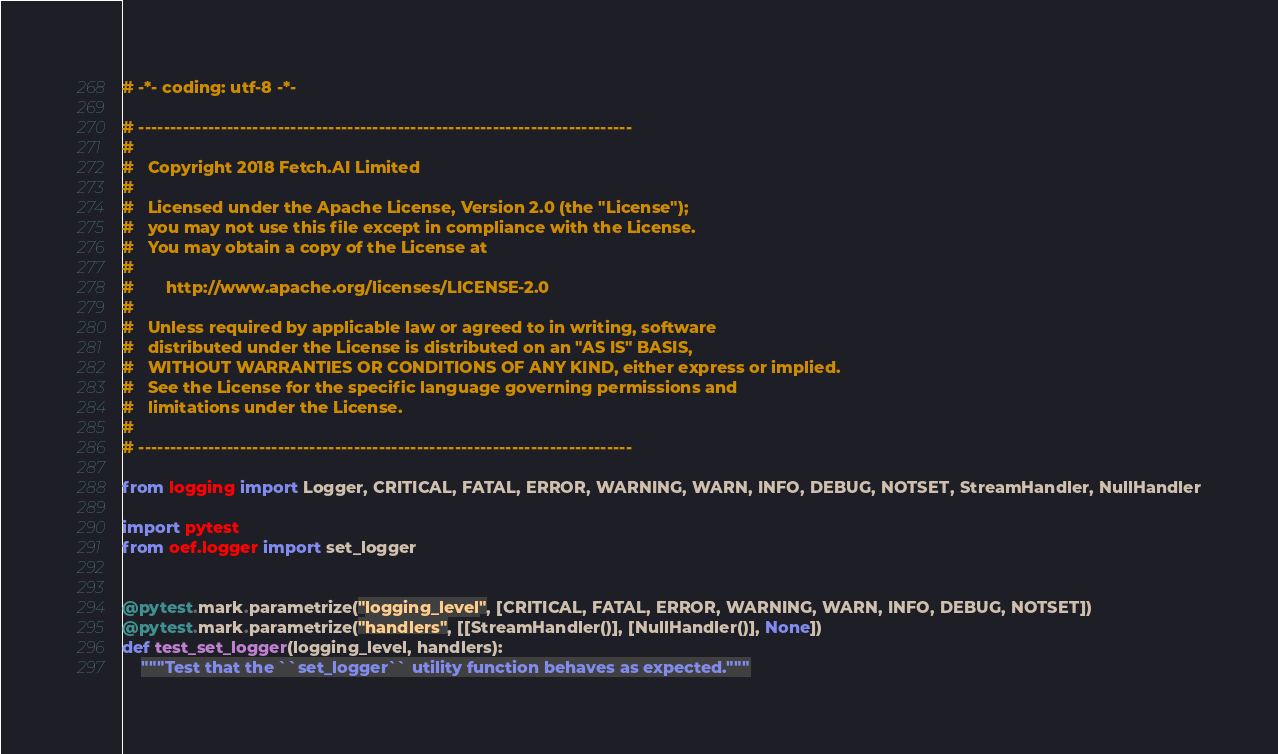<code> <loc_0><loc_0><loc_500><loc_500><_Python_># -*- coding: utf-8 -*-

# ------------------------------------------------------------------------------
#
#   Copyright 2018 Fetch.AI Limited
#
#   Licensed under the Apache License, Version 2.0 (the "License");
#   you may not use this file except in compliance with the License.
#   You may obtain a copy of the License at
#
#       http://www.apache.org/licenses/LICENSE-2.0
#
#   Unless required by applicable law or agreed to in writing, software
#   distributed under the License is distributed on an "AS IS" BASIS,
#   WITHOUT WARRANTIES OR CONDITIONS OF ANY KIND, either express or implied.
#   See the License for the specific language governing permissions and
#   limitations under the License.
#
# ------------------------------------------------------------------------------

from logging import Logger, CRITICAL, FATAL, ERROR, WARNING, WARN, INFO, DEBUG, NOTSET, StreamHandler, NullHandler

import pytest
from oef.logger import set_logger


@pytest.mark.parametrize("logging_level", [CRITICAL, FATAL, ERROR, WARNING, WARN, INFO, DEBUG, NOTSET])
@pytest.mark.parametrize("handlers", [[StreamHandler()], [NullHandler()], None])
def test_set_logger(logging_level, handlers):
    """Test that the ``set_logger`` utility function behaves as expected."""</code> 